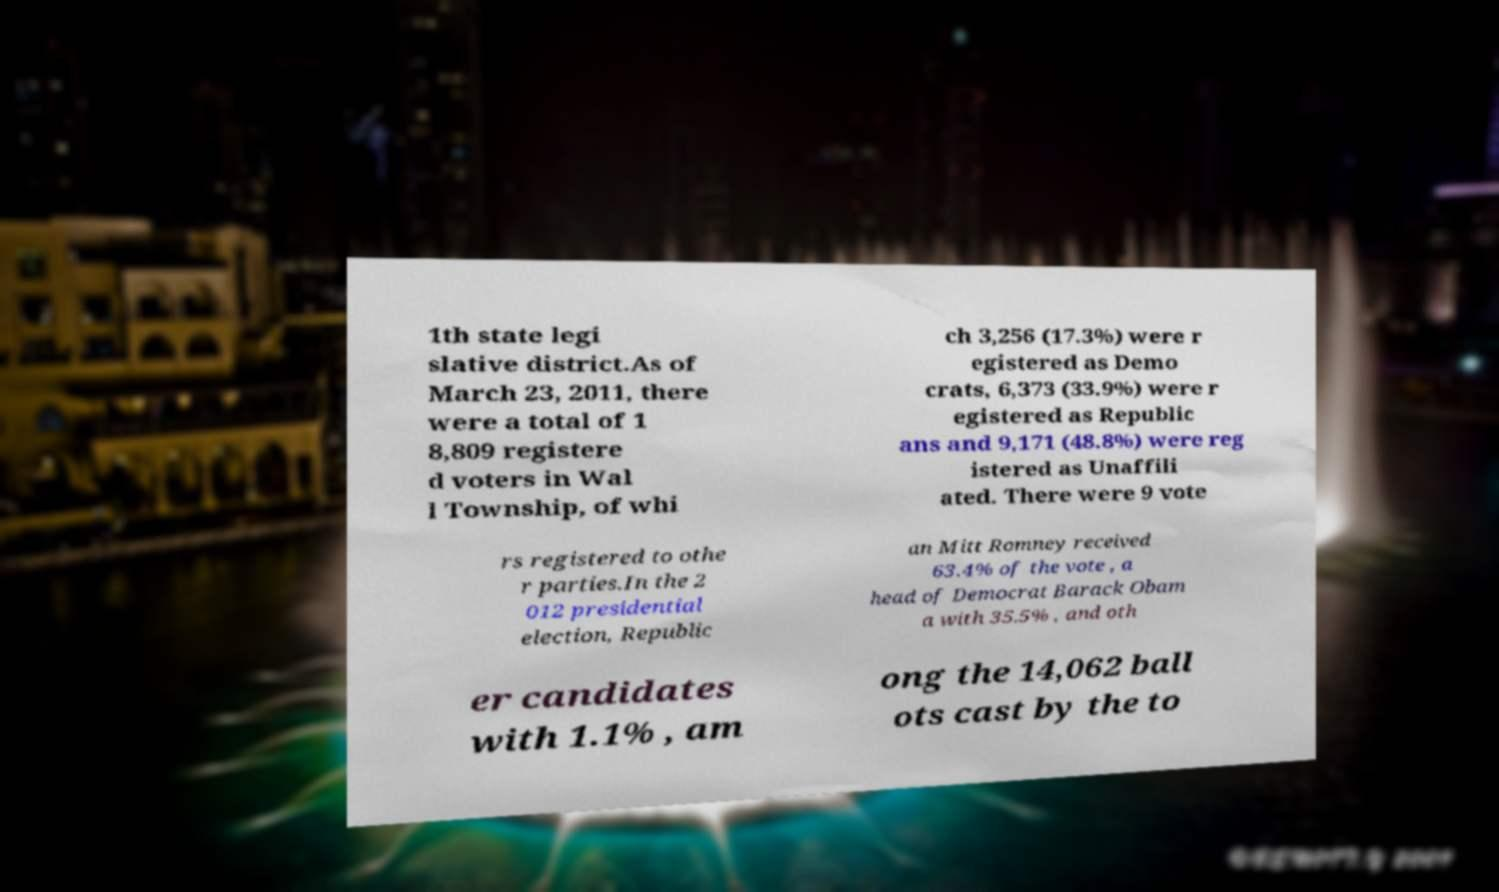Please identify and transcribe the text found in this image. 1th state legi slative district.As of March 23, 2011, there were a total of 1 8,809 registere d voters in Wal l Township, of whi ch 3,256 (17.3%) were r egistered as Demo crats, 6,373 (33.9%) were r egistered as Republic ans and 9,171 (48.8%) were reg istered as Unaffili ated. There were 9 vote rs registered to othe r parties.In the 2 012 presidential election, Republic an Mitt Romney received 63.4% of the vote , a head of Democrat Barack Obam a with 35.5% , and oth er candidates with 1.1% , am ong the 14,062 ball ots cast by the to 